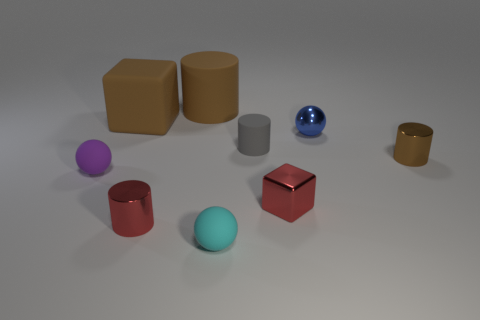How many other cylinders have the same size as the gray cylinder?
Provide a succinct answer. 2. What material is the cyan thing that is the same shape as the small blue metallic thing?
Offer a very short reply. Rubber. Is the gray matte object the same shape as the small purple object?
Give a very brief answer. No. What number of large brown rubber objects are to the left of the cyan ball?
Offer a terse response. 2. There is a red shiny object that is in front of the red object that is to the right of the big matte cylinder; what shape is it?
Give a very brief answer. Cylinder. There is a gray thing that is made of the same material as the small cyan sphere; what is its shape?
Make the answer very short. Cylinder. Is the size of the ball that is to the left of the brown block the same as the brown object that is behind the brown matte block?
Your answer should be very brief. No. What is the shape of the thing to the right of the blue ball?
Your answer should be very brief. Cylinder. What is the color of the metallic cube?
Your answer should be very brief. Red. There is a brown cube; does it have the same size as the rubber sphere that is on the right side of the tiny purple thing?
Your answer should be very brief. No. 